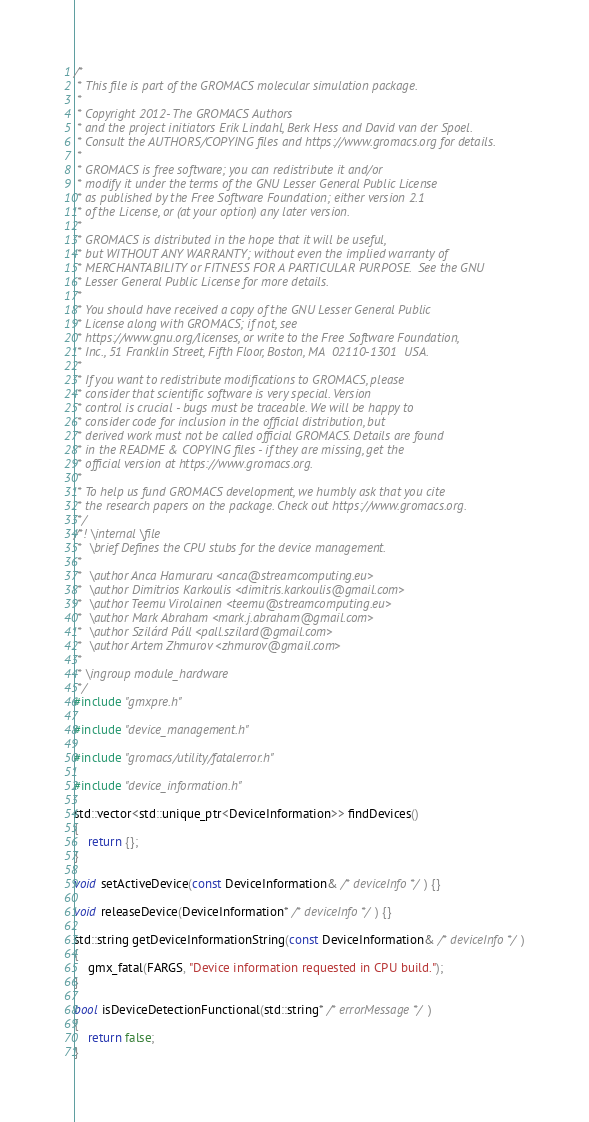<code> <loc_0><loc_0><loc_500><loc_500><_C++_>/*
 * This file is part of the GROMACS molecular simulation package.
 *
 * Copyright 2012- The GROMACS Authors
 * and the project initiators Erik Lindahl, Berk Hess and David van der Spoel.
 * Consult the AUTHORS/COPYING files and https://www.gromacs.org for details.
 *
 * GROMACS is free software; you can redistribute it and/or
 * modify it under the terms of the GNU Lesser General Public License
 * as published by the Free Software Foundation; either version 2.1
 * of the License, or (at your option) any later version.
 *
 * GROMACS is distributed in the hope that it will be useful,
 * but WITHOUT ANY WARRANTY; without even the implied warranty of
 * MERCHANTABILITY or FITNESS FOR A PARTICULAR PURPOSE.  See the GNU
 * Lesser General Public License for more details.
 *
 * You should have received a copy of the GNU Lesser General Public
 * License along with GROMACS; if not, see
 * https://www.gnu.org/licenses, or write to the Free Software Foundation,
 * Inc., 51 Franklin Street, Fifth Floor, Boston, MA  02110-1301  USA.
 *
 * If you want to redistribute modifications to GROMACS, please
 * consider that scientific software is very special. Version
 * control is crucial - bugs must be traceable. We will be happy to
 * consider code for inclusion in the official distribution, but
 * derived work must not be called official GROMACS. Details are found
 * in the README & COPYING files - if they are missing, get the
 * official version at https://www.gromacs.org.
 *
 * To help us fund GROMACS development, we humbly ask that you cite
 * the research papers on the package. Check out https://www.gromacs.org.
 */
/*! \internal \file
 *  \brief Defines the CPU stubs for the device management.
 *
 *  \author Anca Hamuraru <anca@streamcomputing.eu>
 *  \author Dimitrios Karkoulis <dimitris.karkoulis@gmail.com>
 *  \author Teemu Virolainen <teemu@streamcomputing.eu>
 *  \author Mark Abraham <mark.j.abraham@gmail.com>
 *  \author Szilárd Páll <pall.szilard@gmail.com>
 *  \author Artem Zhmurov <zhmurov@gmail.com>
 *
 * \ingroup module_hardware
 */
#include "gmxpre.h"

#include "device_management.h"

#include "gromacs/utility/fatalerror.h"

#include "device_information.h"

std::vector<std::unique_ptr<DeviceInformation>> findDevices()
{
    return {};
}

void setActiveDevice(const DeviceInformation& /* deviceInfo */) {}

void releaseDevice(DeviceInformation* /* deviceInfo */) {}

std::string getDeviceInformationString(const DeviceInformation& /* deviceInfo */)
{
    gmx_fatal(FARGS, "Device information requested in CPU build.");
}

bool isDeviceDetectionFunctional(std::string* /* errorMessage */)
{
    return false;
}
</code> 